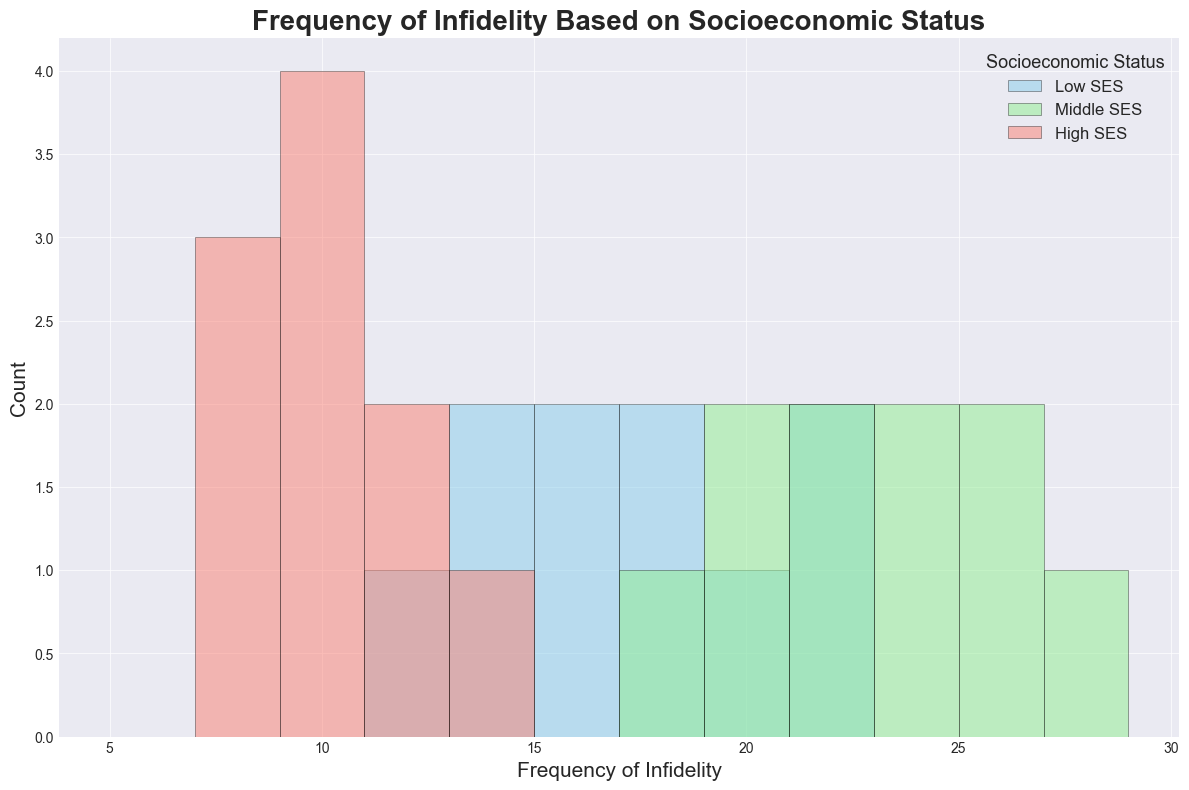What's the modal class of infidelity frequency for the Low SES group? To find the modal class, look for the bin with the highest count in the histogram for the Low SES group (skyblue bars). The bin with the highest count is in the range of 14-16.
Answer: 14-16 Which group has the highest average infidelity frequency? Calculate the average for each group using (sum of frequencies / number of data points). Low SES average: (15+20+13+18+22+17+14+21+16+12)/10 = 16.8. Middle SES average: (25+19+23+24+21+27+20+26+22+18)/10 = 22.5. High SES average: (10+12+8+11+9+10+7+13+10+8)/10 = 9.8. Compare all three.
Answer: Middle What is the range of infidelity frequencies for the High SES group? The range is the difference between the maximum and minimum values in the High SES group. The highest frequency is 13 and the lowest is 7. Thus, the range is 13 - 7 = 6.
Answer: 6 Which socioeconomic group shows the widest distribution of infidelity frequencies? The widest distribution can be seen by comparing the spread of bins. The Low SES group (skyblue bars) spans from 12 to 22, the Middle SES group (lightgreen bars) from 18 to 27, and the High SES group (salmon bars) from 7 to 13.
Answer: Middle How many bins are used to plot the histogram? Count the number of intervals along the x-axis. The bins used range from 5 to 29 with intervals of 2.
Answer: 12 What's the most frequent infidelity range for the Middle SES group? The modal class or bin for Middle SES (lightgreen bars) is the one with the tallest bar, which is in the range of 20-22.
Answer: 20-22 Which SES group has the least variability in infidelity frequency? The High SES group (salmon bars) displays the least variability, as their frequencies are most tightly clustered. Compare the spread of each group, and High SES ranges from 7 to 13.
Answer: High Compare the counts of infidelity frequencies in the range of 18-20 for the Low and Middle SES groups. Check the height of bars in the range of 18-20 for both groups. The Low SES group (skyblue) has 1 bar around this range while the Middle SES group (lightgreen) appears to have more than 1.
Answer: Middle In which infidelity frequency range do the Low and High SES groups overlap the most? Look for the interval where both Low SES (skyblue) and High SES (salmon) bars coincide. The most overlap occurs around the 12-14 range.
Answer: 12-14 